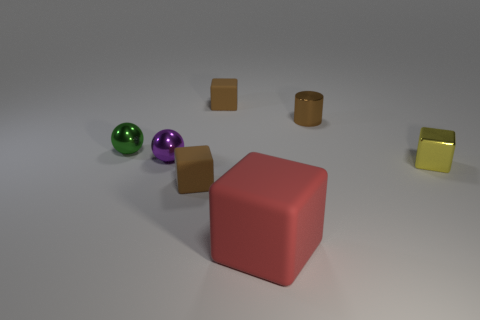Subtract all red matte blocks. How many blocks are left? 3 Subtract all yellow blocks. How many blocks are left? 3 Add 2 red things. How many objects exist? 9 Subtract all cylinders. How many objects are left? 6 Subtract all brown balls. How many brown blocks are left? 2 Subtract all small brown cubes. Subtract all tiny balls. How many objects are left? 3 Add 3 large red objects. How many large red objects are left? 4 Add 1 small green balls. How many small green balls exist? 2 Subtract 0 gray spheres. How many objects are left? 7 Subtract 1 spheres. How many spheres are left? 1 